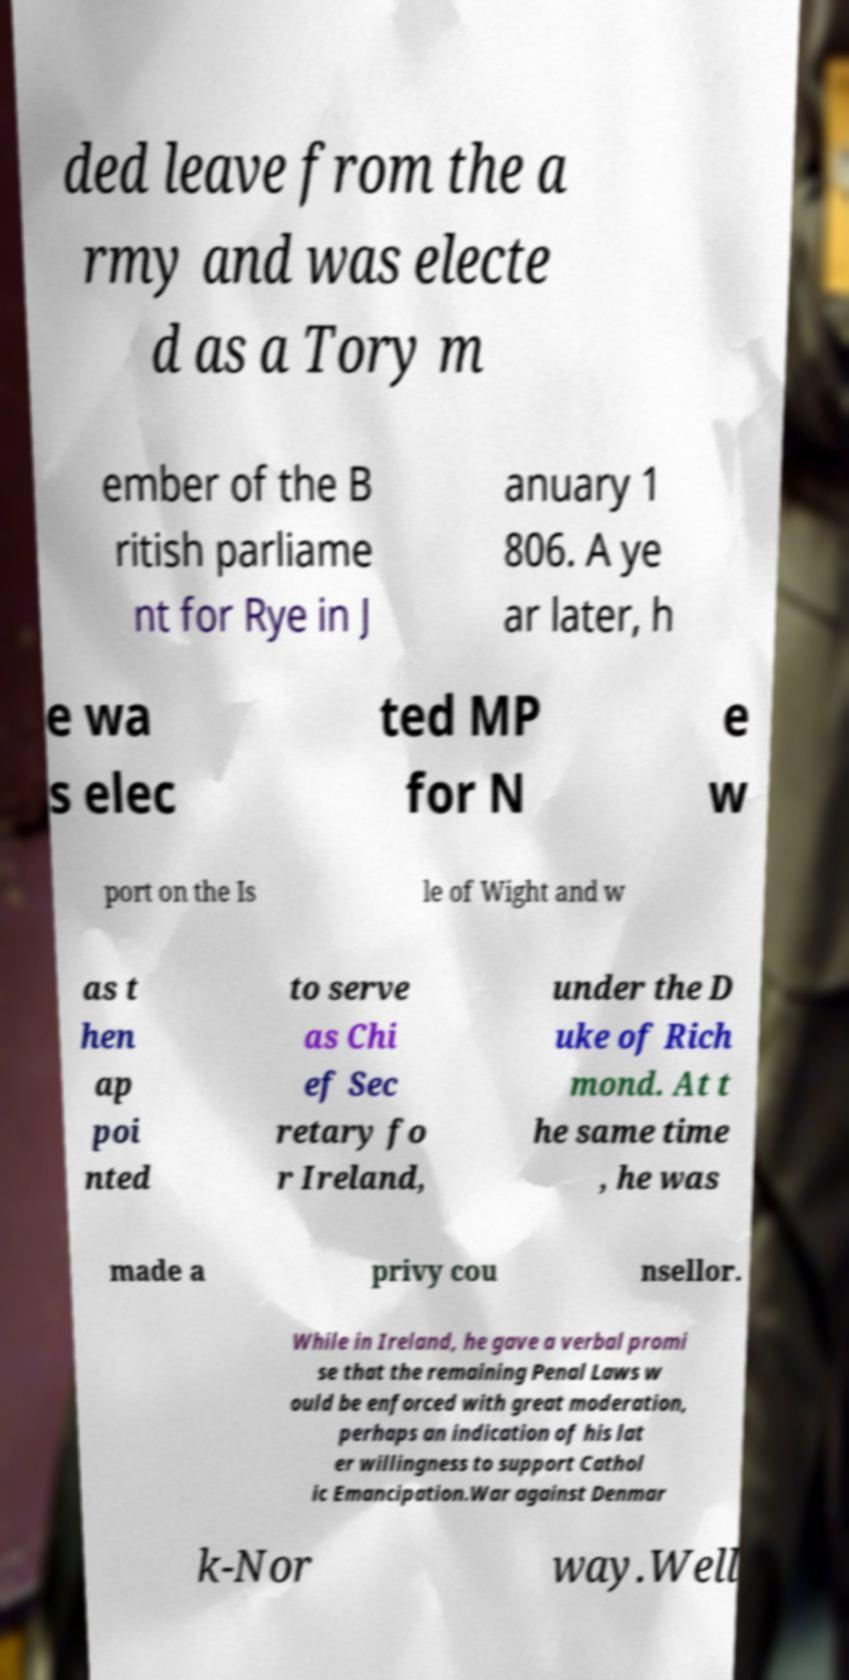Could you extract and type out the text from this image? ded leave from the a rmy and was electe d as a Tory m ember of the B ritish parliame nt for Rye in J anuary 1 806. A ye ar later, h e wa s elec ted MP for N e w port on the Is le of Wight and w as t hen ap poi nted to serve as Chi ef Sec retary fo r Ireland, under the D uke of Rich mond. At t he same time , he was made a privy cou nsellor. While in Ireland, he gave a verbal promi se that the remaining Penal Laws w ould be enforced with great moderation, perhaps an indication of his lat er willingness to support Cathol ic Emancipation.War against Denmar k-Nor way.Well 